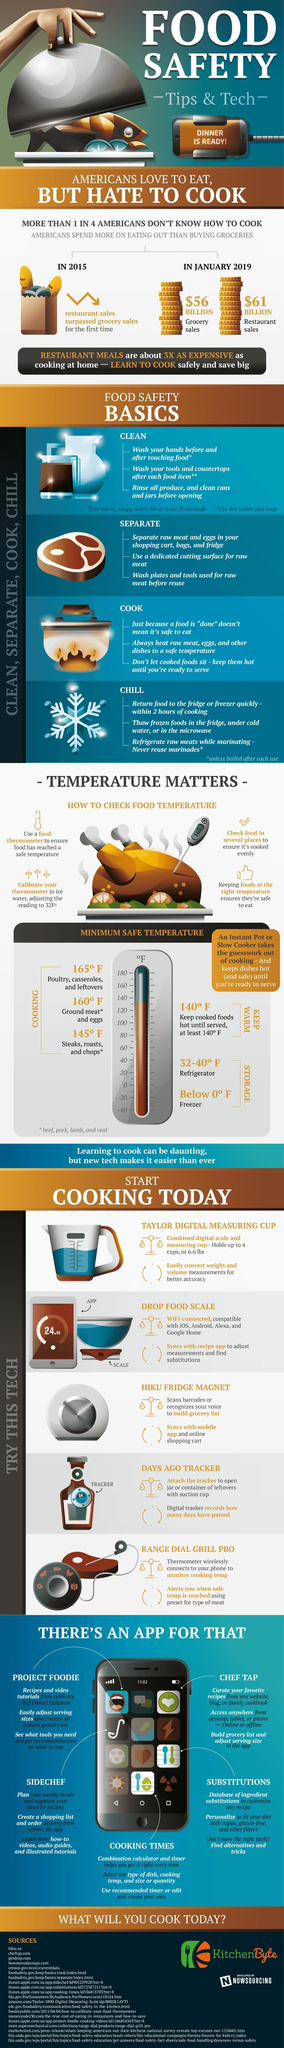What is the minimum safe temperature for cooking poultry in degree Fahrenheit?
Answer the question with a short phrase. 165 What is the total sales generated by restaurant industry in the United States in January 2019? $61 BILLION What is the total sales generated by grocery stores in the United States in January 2019? $56 BILLION What is the minimum safe temperature for cooking steaks in degree Fahrenheit? 145 